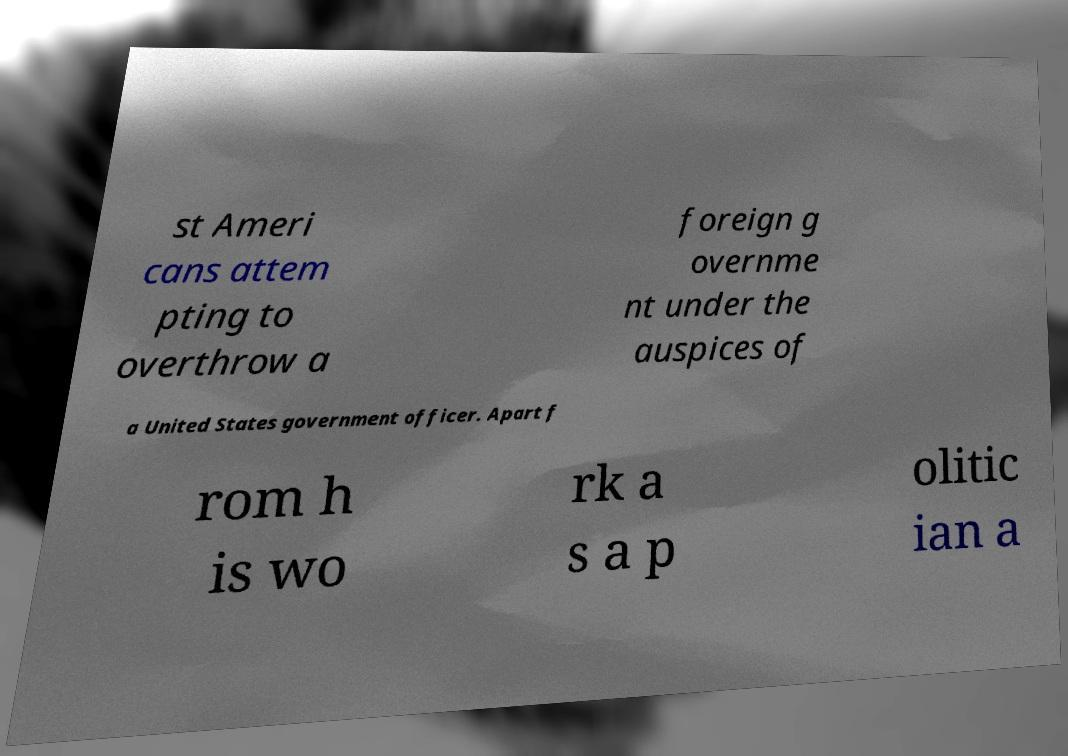Can you accurately transcribe the text from the provided image for me? st Ameri cans attem pting to overthrow a foreign g overnme nt under the auspices of a United States government officer. Apart f rom h is wo rk a s a p olitic ian a 